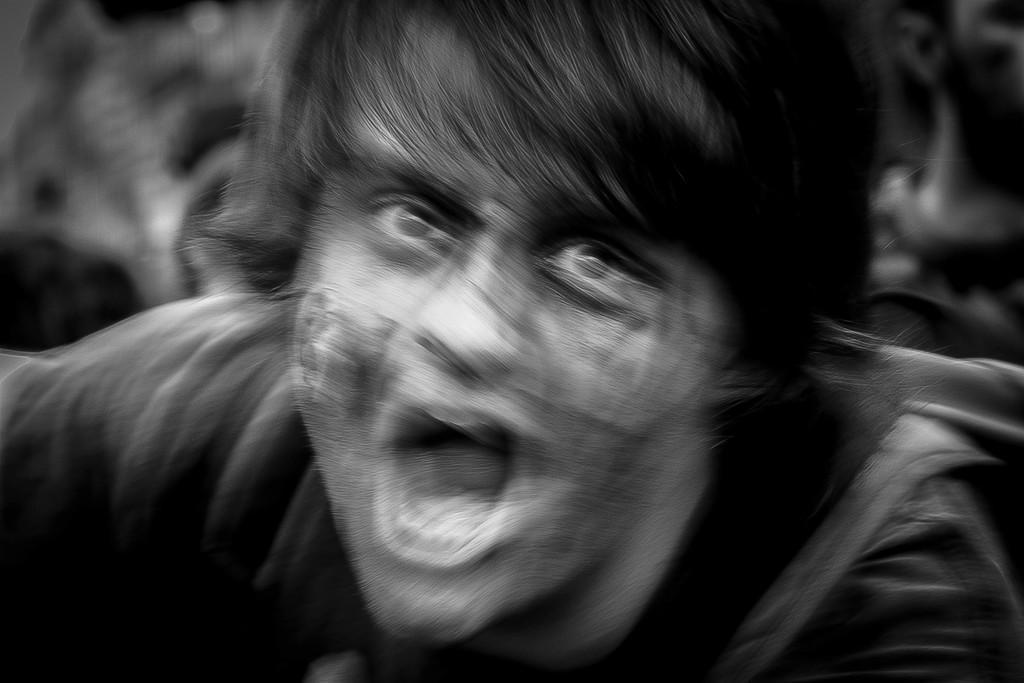Please provide a concise description of this image. In this picture we can see a person and in the background we can see it is blurry. 